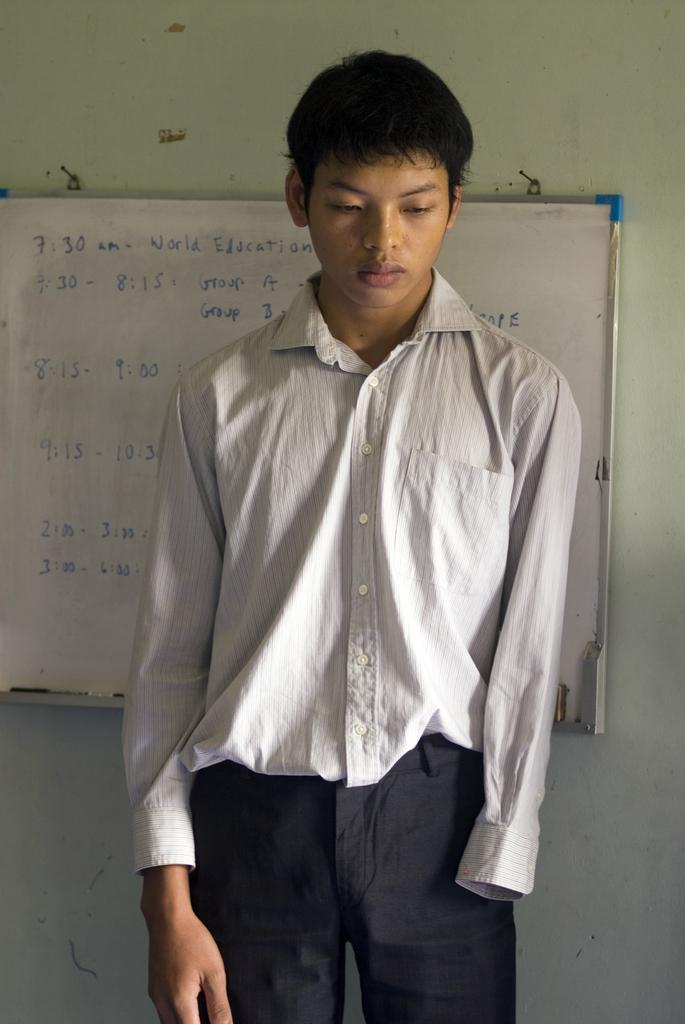What is the main subject of the image? There is a man standing in the image. Can you describe anything in the background of the image? There is a board on a wall in the background of the image. How many clovers can be seen growing on the man's hat in the image? There are no clovers visible in the image, as it features a man standing and a board on a wall in the background. 